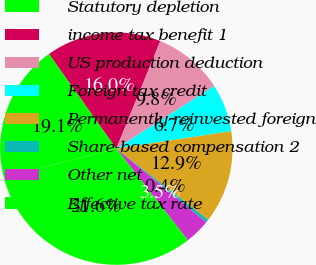Convert chart to OTSL. <chart><loc_0><loc_0><loc_500><loc_500><pie_chart><fcel>Statutory depletion<fcel>income tax benefit 1<fcel>US production deduction<fcel>Foreign tax credit<fcel>Permanently reinvested foreign<fcel>Share-based compensation 2<fcel>Other net<fcel>Effective tax rate<nl><fcel>19.13%<fcel>16.01%<fcel>9.77%<fcel>6.66%<fcel>12.89%<fcel>0.42%<fcel>3.54%<fcel>31.58%<nl></chart> 